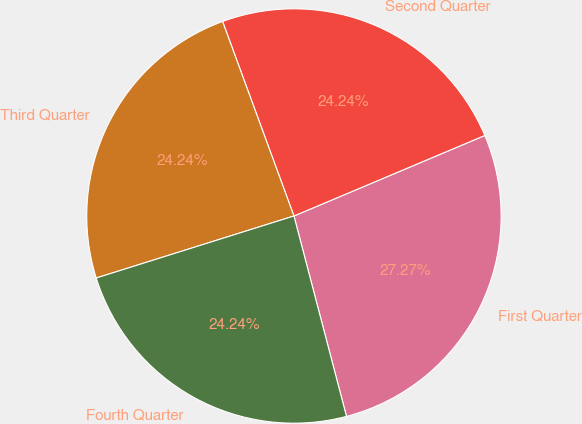<chart> <loc_0><loc_0><loc_500><loc_500><pie_chart><fcel>First Quarter<fcel>Second Quarter<fcel>Third Quarter<fcel>Fourth Quarter<nl><fcel>27.27%<fcel>24.24%<fcel>24.24%<fcel>24.24%<nl></chart> 